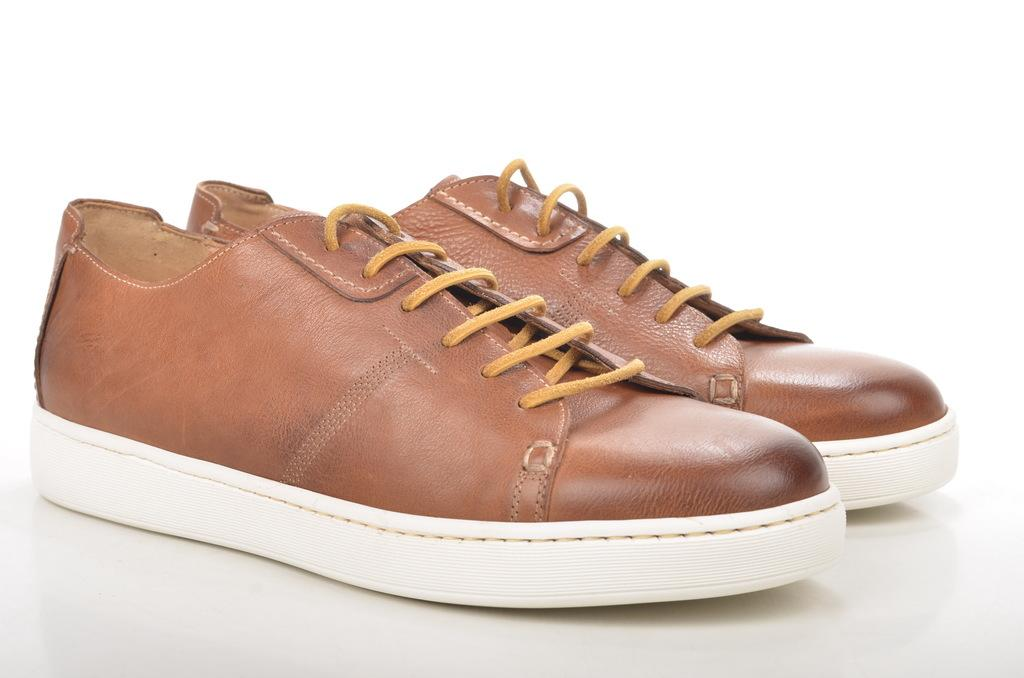What objects are present in the image? There are shoes in the image. What is the color of the surface on which the shoes are placed? The shoes are on a white color surface. Where is the robin located in the image? There is no robin present in the image; it only features shoes on a white surface. 